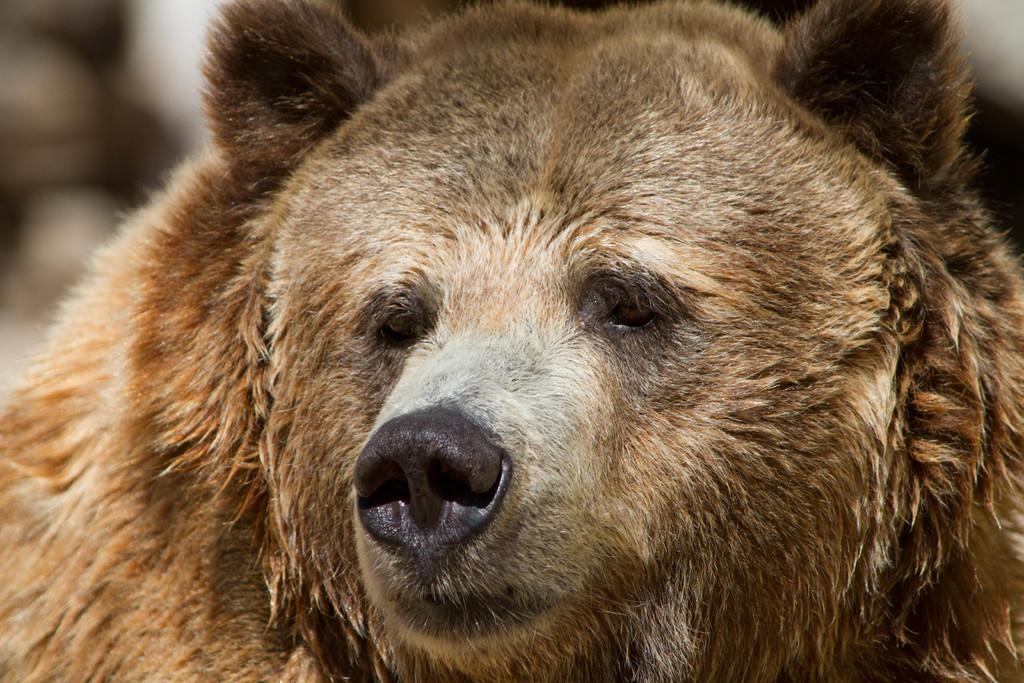How would you summarize this image in a sentence or two? In this picture we can see an animal. 